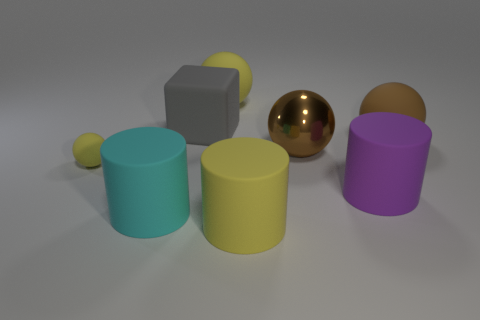Subtract all purple spheres. Subtract all cyan blocks. How many spheres are left? 4 Add 2 gray blocks. How many objects exist? 10 Subtract all cylinders. How many objects are left? 5 Add 2 purple cylinders. How many purple cylinders are left? 3 Add 5 small purple matte blocks. How many small purple matte blocks exist? 5 Subtract 0 blue blocks. How many objects are left? 8 Subtract all large metal spheres. Subtract all large cyan matte things. How many objects are left? 6 